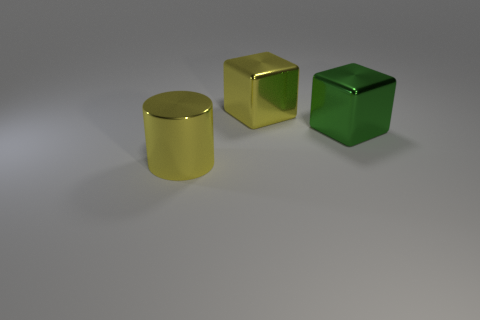There is a thing that is both to the left of the green metal block and in front of the large yellow metal cube; what is its color? The object you're referring to appears to be the smaller yellow metal cube located to the left of the green metal block and in front of the larger yellow metal cylinder. 